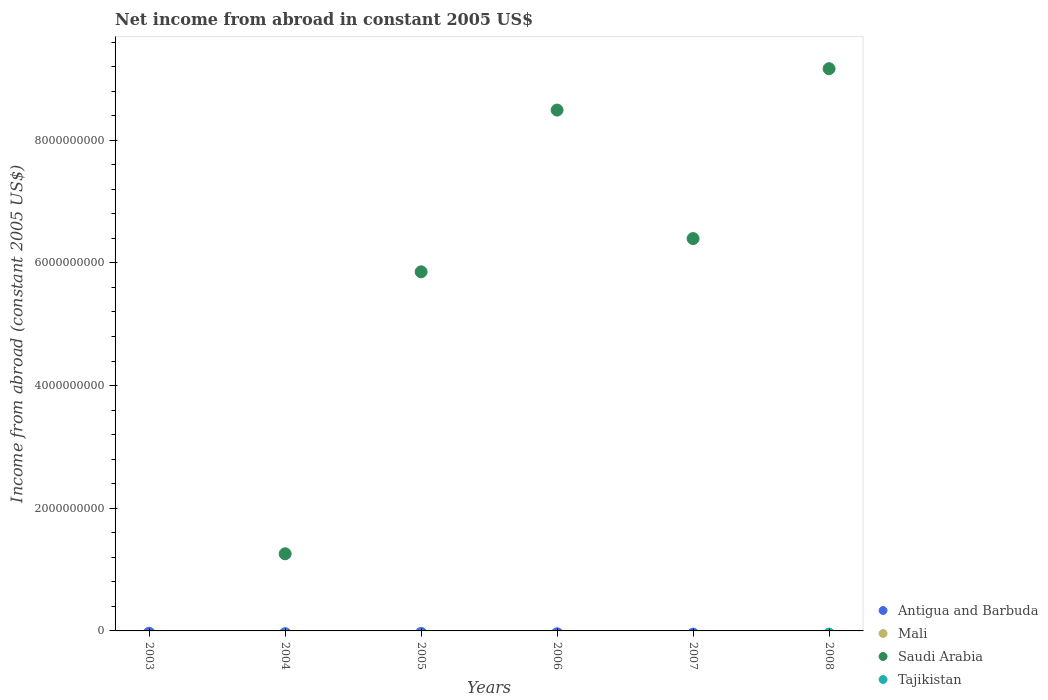Is the number of dotlines equal to the number of legend labels?
Make the answer very short. No. What is the net income from abroad in Tajikistan in 2006?
Ensure brevity in your answer.  0. Across all years, what is the maximum net income from abroad in Saudi Arabia?
Your answer should be compact. 9.17e+09. Across all years, what is the minimum net income from abroad in Saudi Arabia?
Keep it short and to the point. 0. In which year was the net income from abroad in Saudi Arabia maximum?
Make the answer very short. 2008. What is the average net income from abroad in Antigua and Barbuda per year?
Offer a terse response. 0. In how many years, is the net income from abroad in Mali greater than 2800000000 US$?
Provide a succinct answer. 0. What is the difference between the highest and the second highest net income from abroad in Saudi Arabia?
Your answer should be very brief. 6.75e+08. What is the difference between the highest and the lowest net income from abroad in Saudi Arabia?
Your answer should be very brief. 9.17e+09. In how many years, is the net income from abroad in Antigua and Barbuda greater than the average net income from abroad in Antigua and Barbuda taken over all years?
Offer a terse response. 0. Is it the case that in every year, the sum of the net income from abroad in Tajikistan and net income from abroad in Mali  is greater than the sum of net income from abroad in Saudi Arabia and net income from abroad in Antigua and Barbuda?
Give a very brief answer. No. Is the net income from abroad in Tajikistan strictly greater than the net income from abroad in Mali over the years?
Make the answer very short. Yes. How many dotlines are there?
Offer a terse response. 1. How many years are there in the graph?
Your answer should be compact. 6. Does the graph contain any zero values?
Provide a succinct answer. Yes. Does the graph contain grids?
Keep it short and to the point. No. What is the title of the graph?
Give a very brief answer. Net income from abroad in constant 2005 US$. What is the label or title of the X-axis?
Ensure brevity in your answer.  Years. What is the label or title of the Y-axis?
Your answer should be compact. Income from abroad (constant 2005 US$). What is the Income from abroad (constant 2005 US$) of Saudi Arabia in 2003?
Provide a succinct answer. 0. What is the Income from abroad (constant 2005 US$) of Saudi Arabia in 2004?
Keep it short and to the point. 1.26e+09. What is the Income from abroad (constant 2005 US$) in Tajikistan in 2004?
Ensure brevity in your answer.  0. What is the Income from abroad (constant 2005 US$) in Saudi Arabia in 2005?
Make the answer very short. 5.86e+09. What is the Income from abroad (constant 2005 US$) of Tajikistan in 2005?
Ensure brevity in your answer.  0. What is the Income from abroad (constant 2005 US$) of Mali in 2006?
Ensure brevity in your answer.  0. What is the Income from abroad (constant 2005 US$) of Saudi Arabia in 2006?
Your answer should be very brief. 8.49e+09. What is the Income from abroad (constant 2005 US$) of Tajikistan in 2006?
Keep it short and to the point. 0. What is the Income from abroad (constant 2005 US$) in Mali in 2007?
Your response must be concise. 0. What is the Income from abroad (constant 2005 US$) of Saudi Arabia in 2007?
Provide a succinct answer. 6.40e+09. What is the Income from abroad (constant 2005 US$) in Antigua and Barbuda in 2008?
Provide a succinct answer. 0. What is the Income from abroad (constant 2005 US$) of Saudi Arabia in 2008?
Offer a terse response. 9.17e+09. Across all years, what is the maximum Income from abroad (constant 2005 US$) in Saudi Arabia?
Offer a terse response. 9.17e+09. Across all years, what is the minimum Income from abroad (constant 2005 US$) of Saudi Arabia?
Keep it short and to the point. 0. What is the total Income from abroad (constant 2005 US$) in Saudi Arabia in the graph?
Provide a short and direct response. 3.12e+1. What is the difference between the Income from abroad (constant 2005 US$) in Saudi Arabia in 2004 and that in 2005?
Your response must be concise. -4.60e+09. What is the difference between the Income from abroad (constant 2005 US$) in Saudi Arabia in 2004 and that in 2006?
Ensure brevity in your answer.  -7.23e+09. What is the difference between the Income from abroad (constant 2005 US$) in Saudi Arabia in 2004 and that in 2007?
Offer a very short reply. -5.14e+09. What is the difference between the Income from abroad (constant 2005 US$) of Saudi Arabia in 2004 and that in 2008?
Make the answer very short. -7.91e+09. What is the difference between the Income from abroad (constant 2005 US$) of Saudi Arabia in 2005 and that in 2006?
Keep it short and to the point. -2.64e+09. What is the difference between the Income from abroad (constant 2005 US$) in Saudi Arabia in 2005 and that in 2007?
Your answer should be very brief. -5.42e+08. What is the difference between the Income from abroad (constant 2005 US$) of Saudi Arabia in 2005 and that in 2008?
Your answer should be very brief. -3.31e+09. What is the difference between the Income from abroad (constant 2005 US$) in Saudi Arabia in 2006 and that in 2007?
Your answer should be very brief. 2.10e+09. What is the difference between the Income from abroad (constant 2005 US$) in Saudi Arabia in 2006 and that in 2008?
Give a very brief answer. -6.75e+08. What is the difference between the Income from abroad (constant 2005 US$) of Saudi Arabia in 2007 and that in 2008?
Your response must be concise. -2.77e+09. What is the average Income from abroad (constant 2005 US$) of Antigua and Barbuda per year?
Offer a terse response. 0. What is the average Income from abroad (constant 2005 US$) in Saudi Arabia per year?
Your answer should be compact. 5.19e+09. What is the average Income from abroad (constant 2005 US$) of Tajikistan per year?
Your answer should be very brief. 0. What is the ratio of the Income from abroad (constant 2005 US$) of Saudi Arabia in 2004 to that in 2005?
Keep it short and to the point. 0.21. What is the ratio of the Income from abroad (constant 2005 US$) of Saudi Arabia in 2004 to that in 2006?
Make the answer very short. 0.15. What is the ratio of the Income from abroad (constant 2005 US$) in Saudi Arabia in 2004 to that in 2007?
Provide a short and direct response. 0.2. What is the ratio of the Income from abroad (constant 2005 US$) of Saudi Arabia in 2004 to that in 2008?
Your answer should be compact. 0.14. What is the ratio of the Income from abroad (constant 2005 US$) in Saudi Arabia in 2005 to that in 2006?
Give a very brief answer. 0.69. What is the ratio of the Income from abroad (constant 2005 US$) of Saudi Arabia in 2005 to that in 2007?
Offer a very short reply. 0.92. What is the ratio of the Income from abroad (constant 2005 US$) of Saudi Arabia in 2005 to that in 2008?
Your response must be concise. 0.64. What is the ratio of the Income from abroad (constant 2005 US$) of Saudi Arabia in 2006 to that in 2007?
Your answer should be compact. 1.33. What is the ratio of the Income from abroad (constant 2005 US$) in Saudi Arabia in 2006 to that in 2008?
Provide a short and direct response. 0.93. What is the ratio of the Income from abroad (constant 2005 US$) of Saudi Arabia in 2007 to that in 2008?
Keep it short and to the point. 0.7. What is the difference between the highest and the second highest Income from abroad (constant 2005 US$) in Saudi Arabia?
Give a very brief answer. 6.75e+08. What is the difference between the highest and the lowest Income from abroad (constant 2005 US$) of Saudi Arabia?
Make the answer very short. 9.17e+09. 